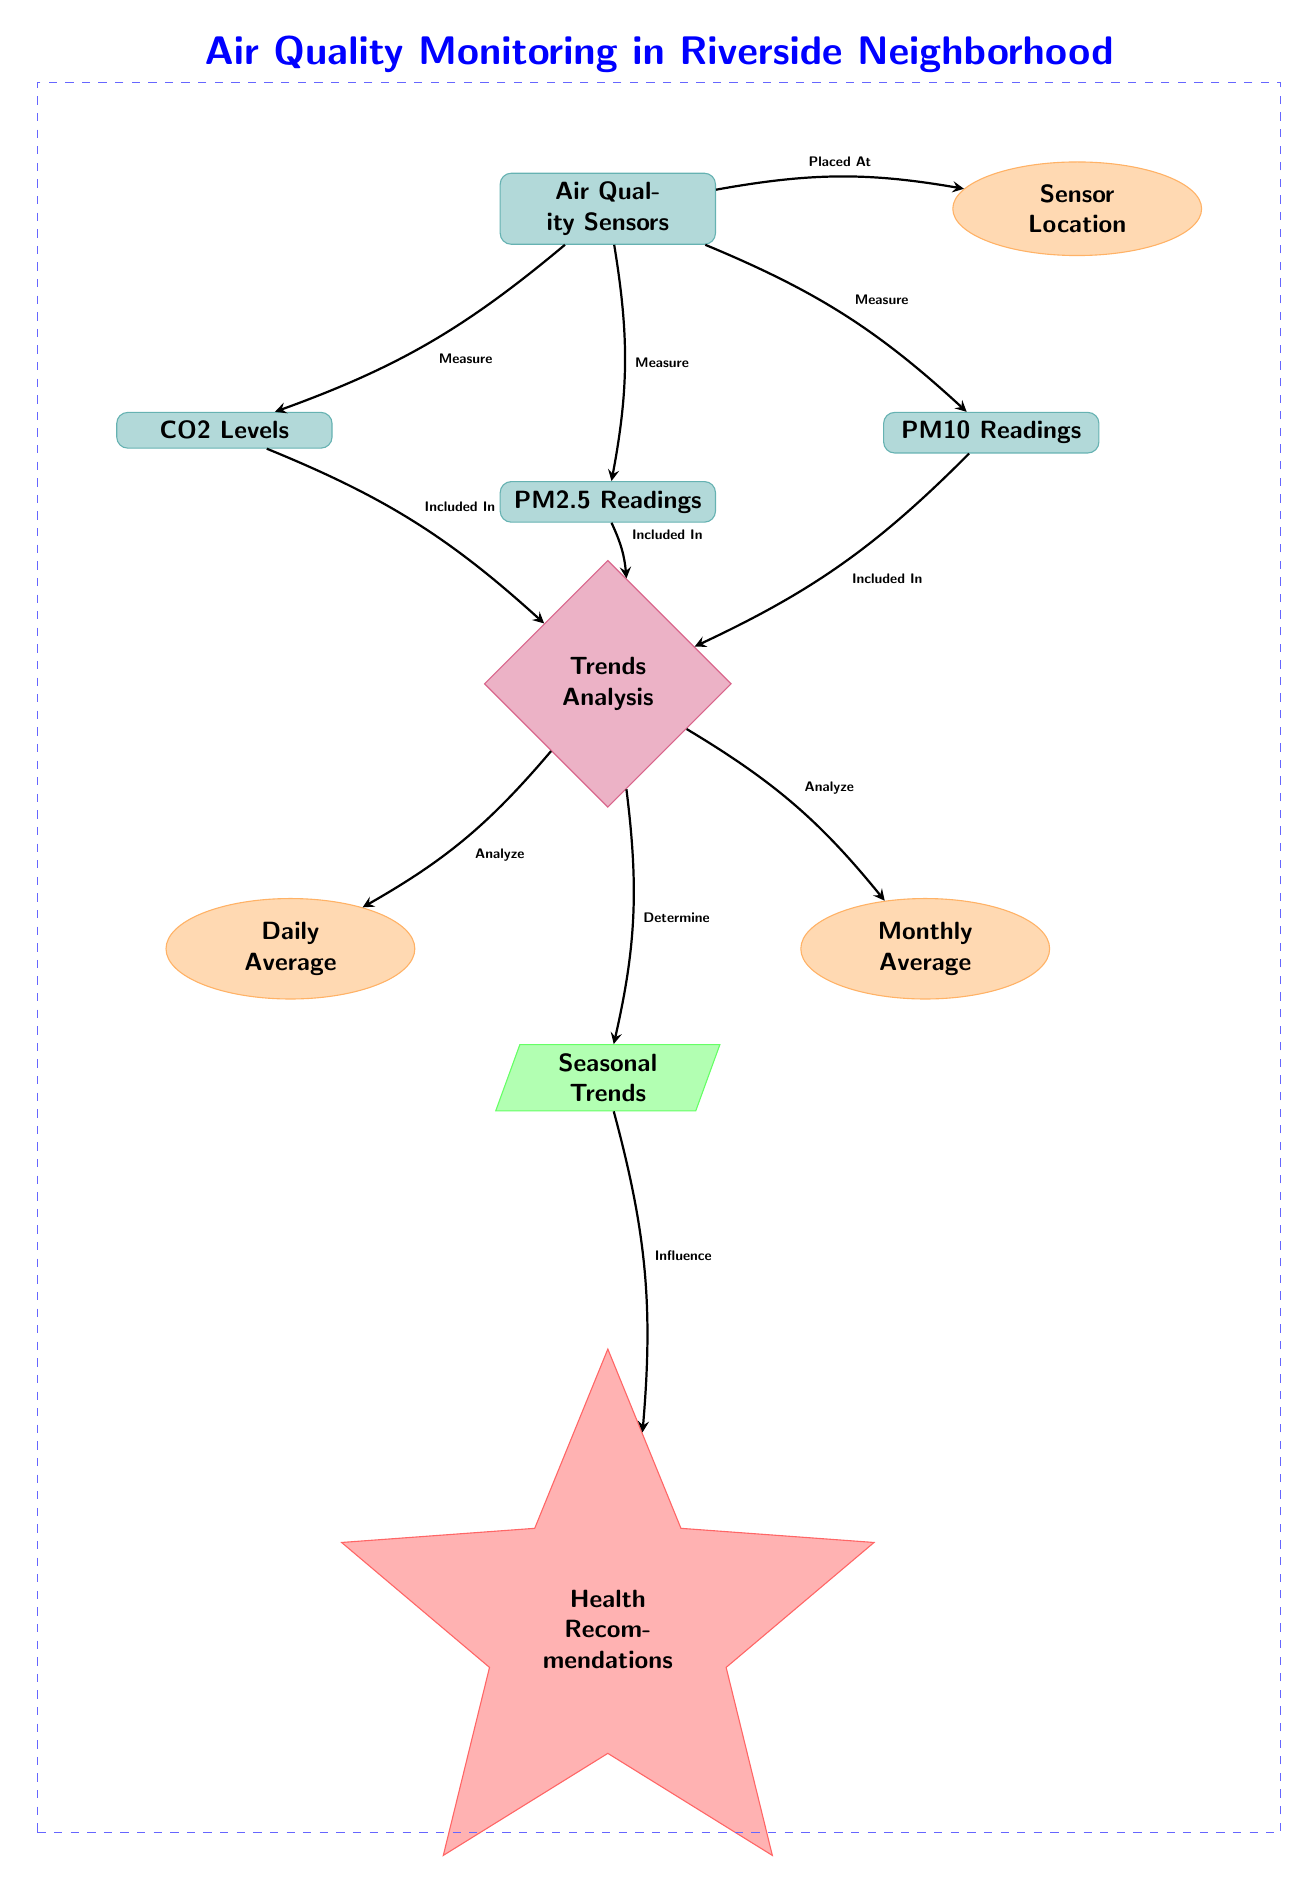What type of data does the air quality monitoring system measure? The diagram shows three types of data being measured by the air quality sensors: PM2.5 Readings, PM10 Readings, and CO2 Levels. These readings are explicitly labeled under the data nodes connected to the sensors node.
Answer: PM2.5 Readings, PM10 Readings, CO2 Levels Where is the air quality monitoring system located? The location of the air quality monitoring system is specified as "Sensor Location," which is connected directly to the "Air Quality Sensors" node. This indicates that the sensors are placed at this particular location for measurement.
Answer: Sensor Location How many readings are included in the trends analysis? The trends analysis node includes three readings: PM2.5, PM10, and CO2. The diagram shows three directed edges leading from each reading to the "Trends Analysis" node, demonstrating these measurements are included in the analysis.
Answer: Three What influences the health recommendations in the diagram? According to the diagram, the "Seasonal Trends" node influences the health recommendations. There is a directed edge leading from the "Seasonal Trends" node to the "Health Recommendations" node, indicating this relationship.
Answer: Seasonal Trends What types of averages are analyzed in the trends analysis? The trends analysis encompasses two types of averages: Daily Average and Monthly Average. These are indicated under the analysis section, linked through edges from the trends node.
Answer: Daily Average, Monthly Average Which node shows the relationship of sensor locations to air quality? The "Sensor Location" node demonstrates the relationship of where the air quality sensors are placed, as evidenced by the direct connection from the "Air Quality Sensors" node.
Answer: Sensor Location What is the purpose of the air quality sensors in the diagram? The primary purpose of the air quality sensors, as indicated in the diagram, is to measure various pollutants, including PM2.5, PM10, and CO2 levels. This information is essential for understanding air quality.
Answer: Measure air quality 